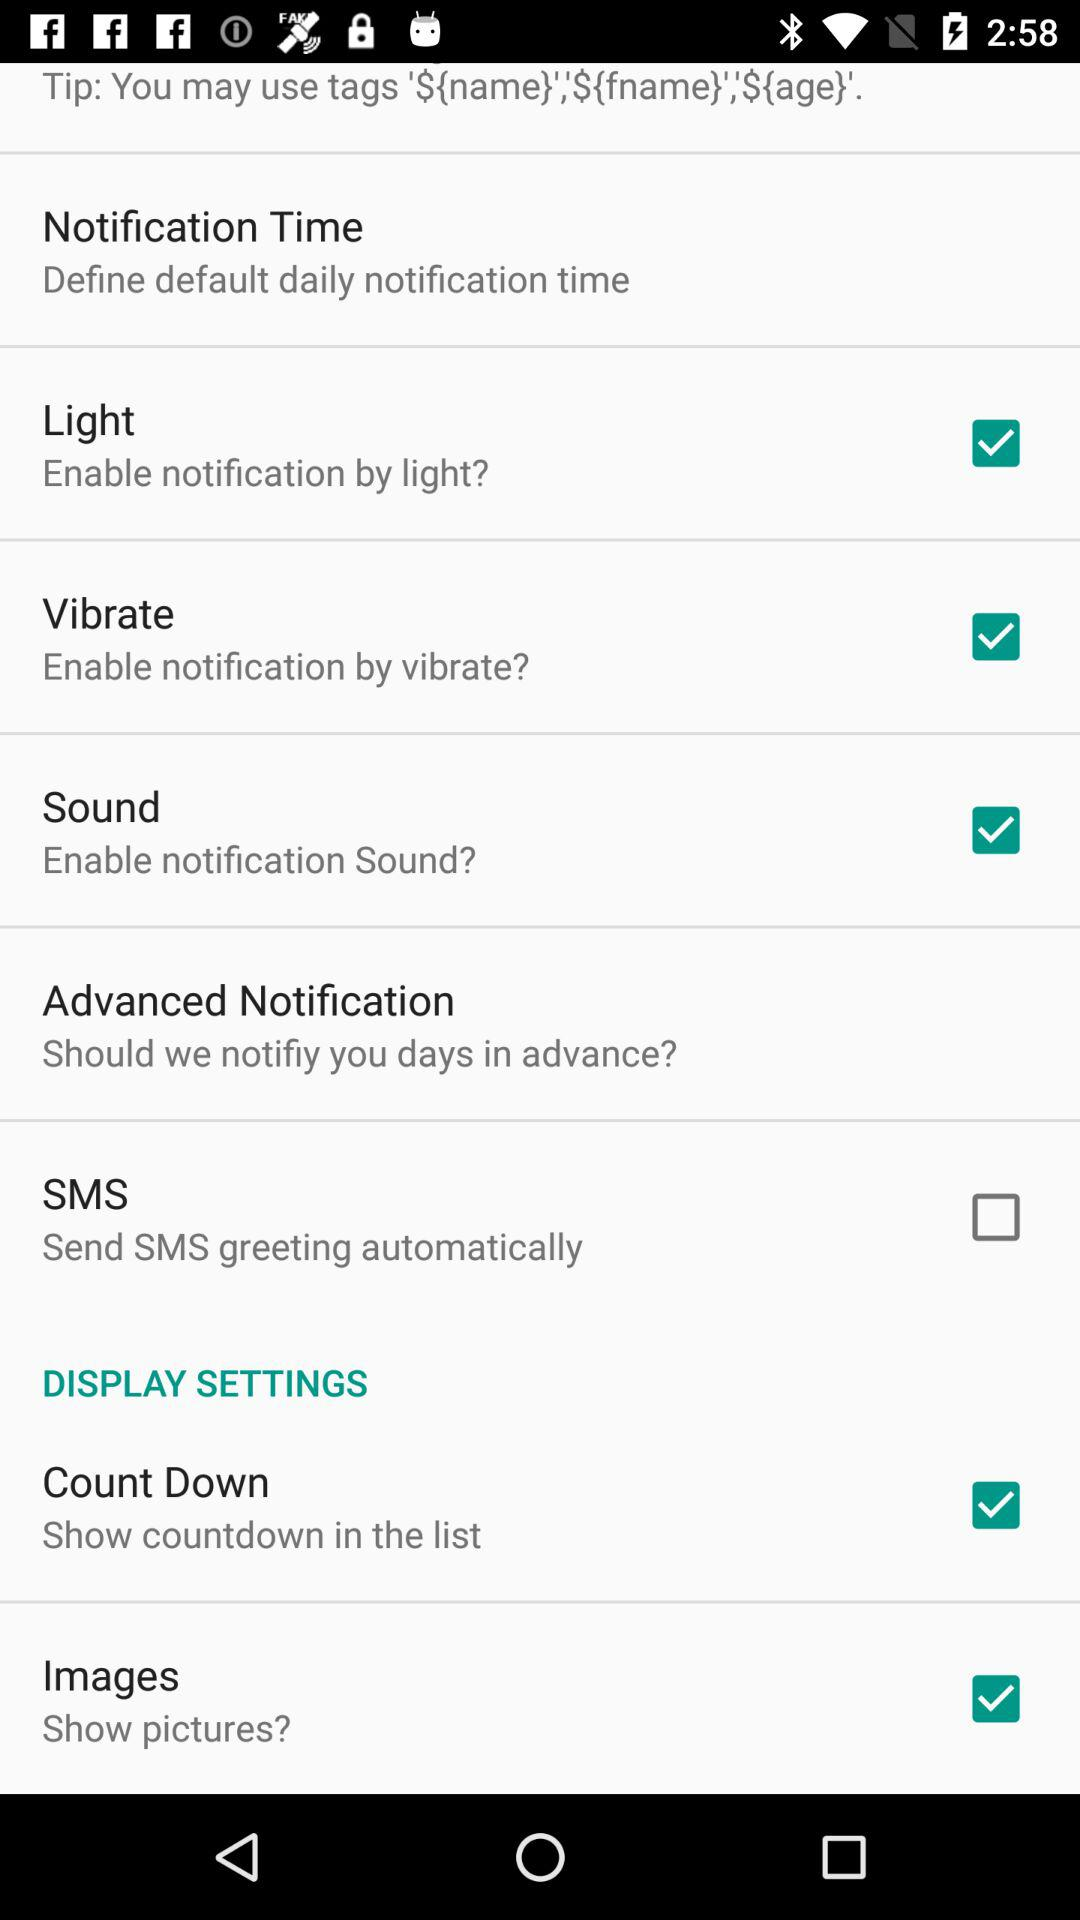What's the status of vibrate? The status is "on". 